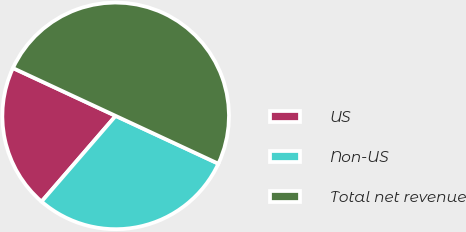Convert chart. <chart><loc_0><loc_0><loc_500><loc_500><pie_chart><fcel>US<fcel>Non-US<fcel>Total net revenue<nl><fcel>20.59%<fcel>29.41%<fcel>50.0%<nl></chart> 